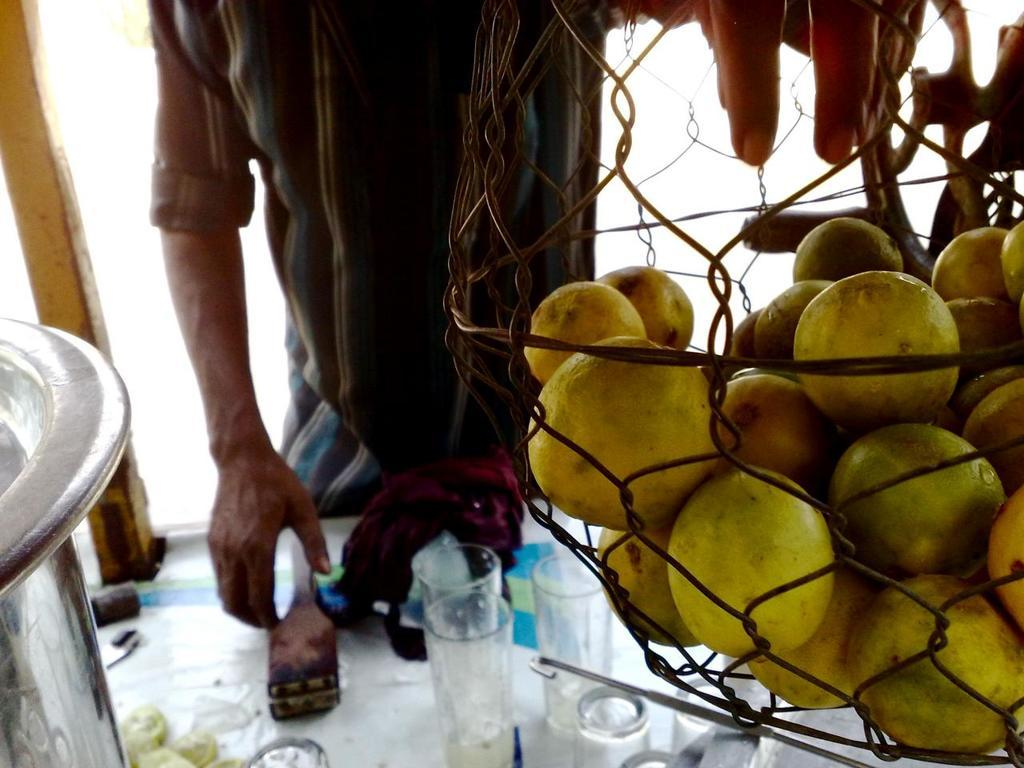What type of fruit is in the basket in the image? There are lemons in a basket in the image. Can you describe the person in the image? There is a person in the image, but no specific details are provided about their appearance or actions. What is in front of the person in the image? There is a table in front of the person in the image. What can be seen on the table in the image? There are glasses and other objects on the table in the image. What type of boat is visible in the image? There is no boat present in the image. What reward is the person receiving for their actions in the image? There is no indication of any reward or action in the image. 